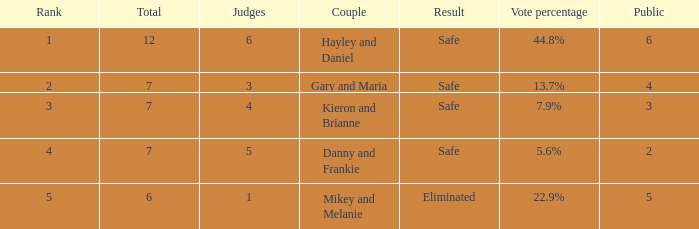What was the maximum rank for the vote percentage of 5.6% 4.0. 